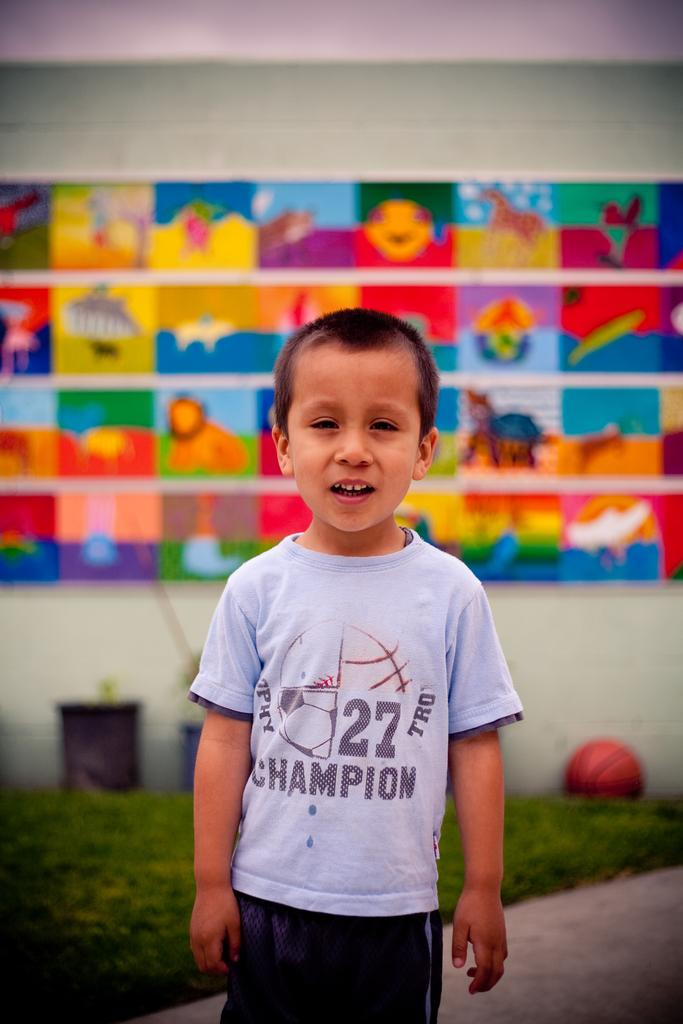What is the main subject of the image? There is a child in the image. Can you describe what the child is wearing? The child is wearing a dress. What can be seen in the background of the image? There are flower pots, a ball on the grass, and a colorful board attached to the wall in the background of the image. What type of quilt is being used as a backdrop for the child in the image? There is no quilt present in the image; it features a child wearing a dress with various elements in the background. 